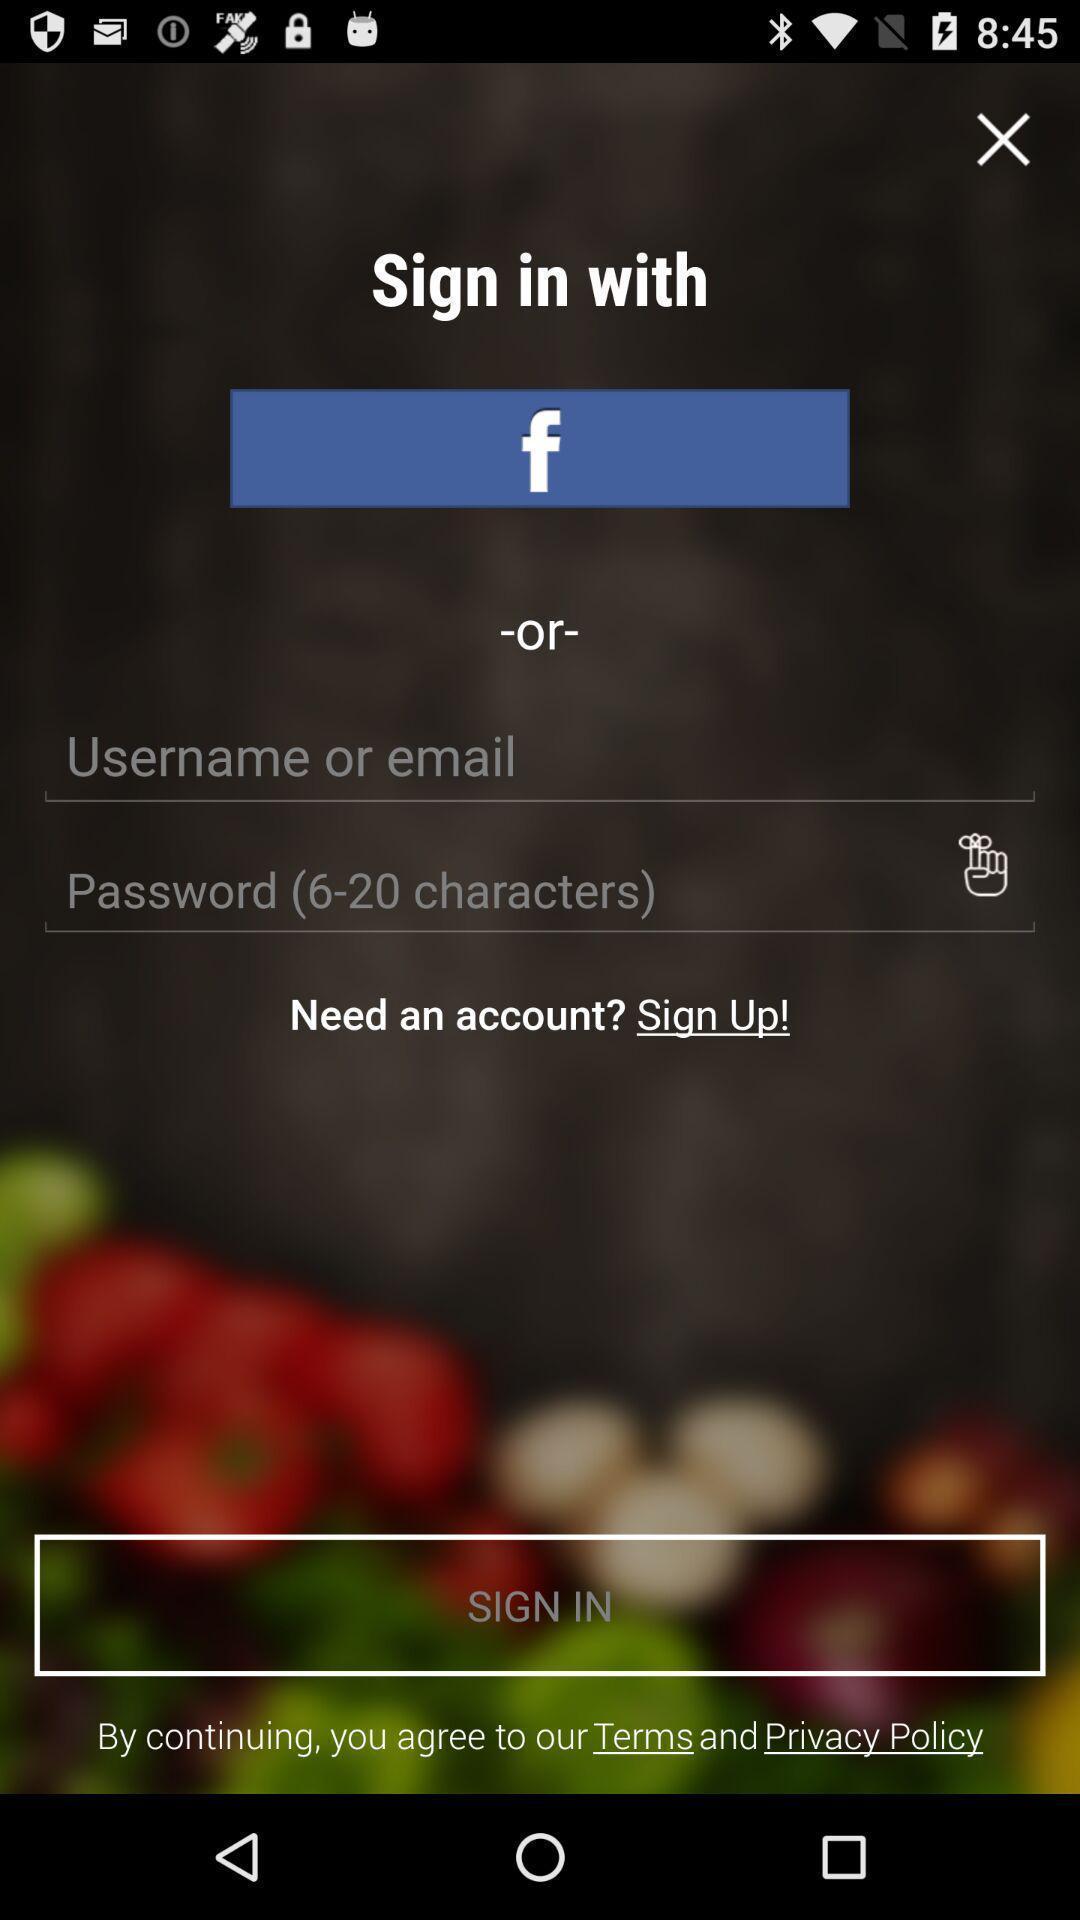Describe the visual elements of this screenshot. Sign up or sign in with an social application displayed. 